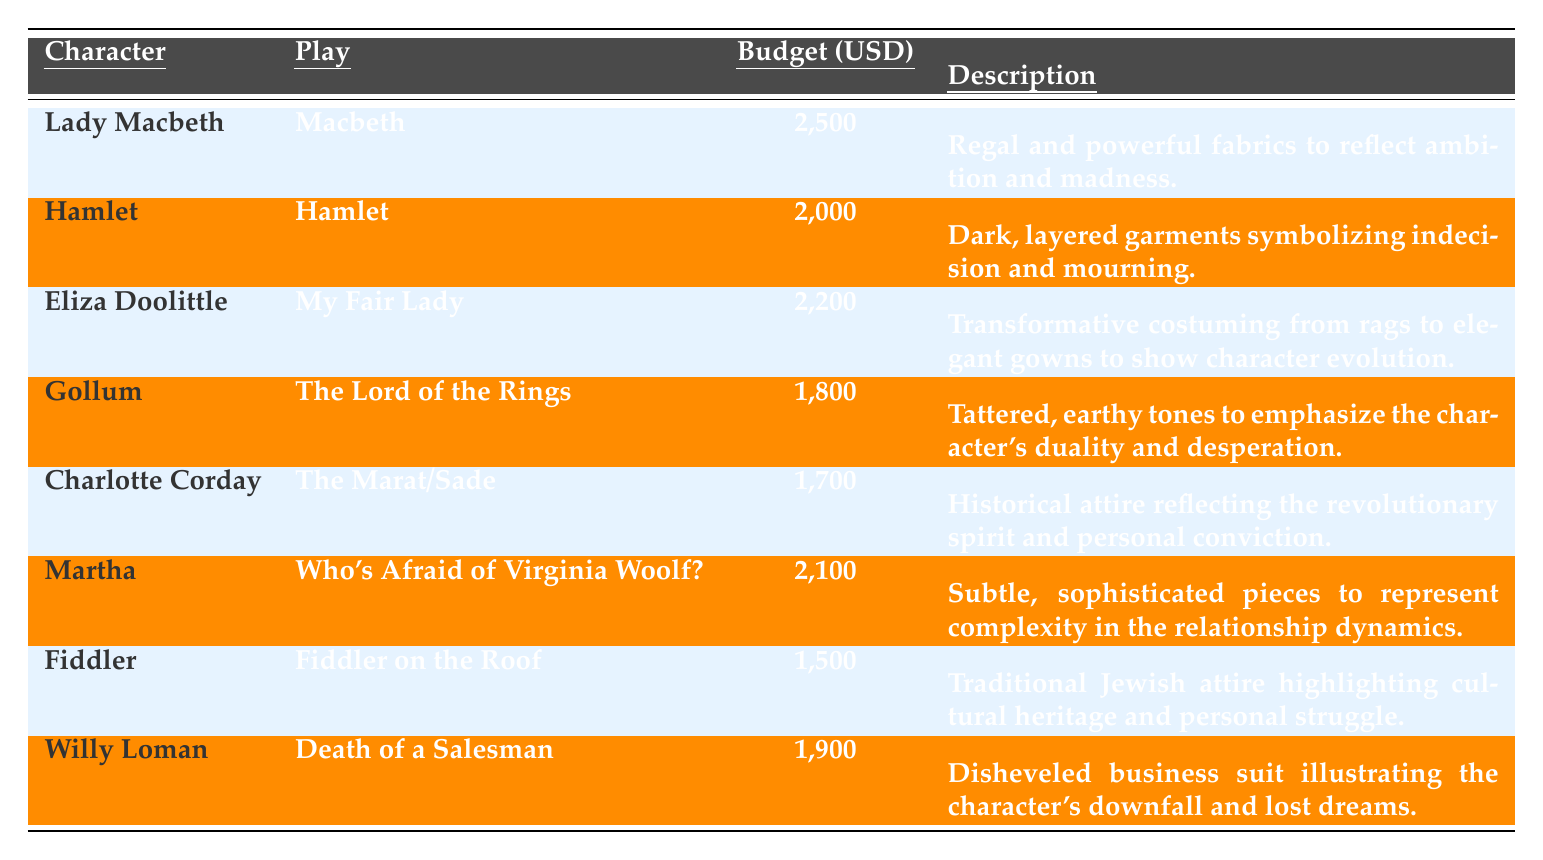What is the highest budget allocation for a character? The table shows each character's budget allocation. Comparing the values, Lady Macbeth has the highest budget allocation at 2,500 USD.
Answer: 2,500 USD Who is allocated a budget of 1,500 USD? Looking through the budget allocations, Fiddler has a budget of 1,500 USD.
Answer: Fiddler Which character from "Hamlet" has a budget less than 2,100 USD? The table shows Hamlet with a budget of 2,000 USD, which is less than 2,100 USD.
Answer: Hamlet What is the total budget allocation for Eliza Doolittle and Martha? The budget for Eliza Doolittle is 2,200 USD and for Martha, it is 2,100 USD. Adding these together gives 2,200 + 2,100 = 4,300 USD.
Answer: 4,300 USD Is Gollum's budget allocation greater than Willy Loman's? Gollum's budget is 1,800 USD, and Willy Loman's is 1,900 USD. Since 1,800 is less than 1,900, the statement is false.
Answer: No What is the average budget allocation for all characters in the table? Adding all the budget allocations gives: 2,500 + 2,000 + 2,200 + 1,800 + 1,700 + 2,100 + 1,500 + 1,900 = 13,700. There are 8 characters, so the average is 13,700 / 8 = 1,712.5 USD.
Answer: 1,712.5 USD Which character has a budget of only 1,700 USD? The table shows that Charlotte Corday has a budget allocation of 1,700 USD.
Answer: Charlotte Corday Among the characters, who has the least budget allocated? Fiddler has the lowest budget allocation of 1,500 USD when comparing all characters listed.
Answer: Fiddler 